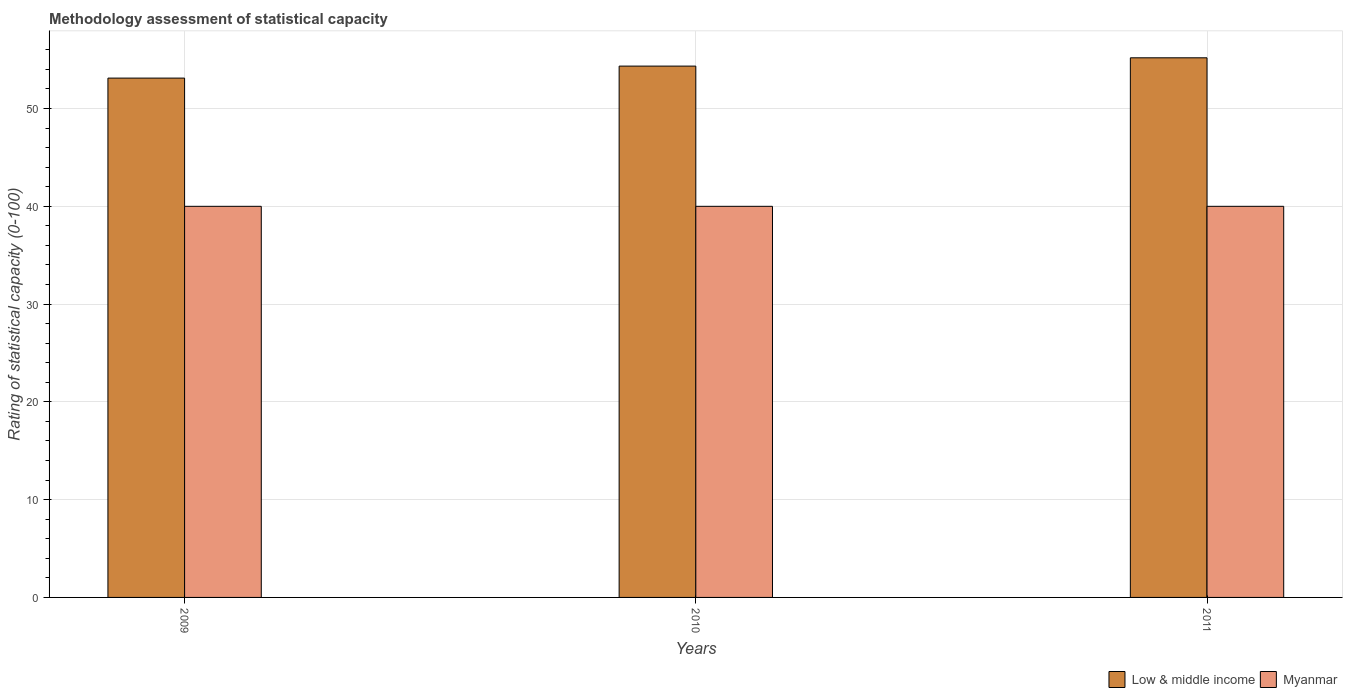How many different coloured bars are there?
Your response must be concise. 2. Are the number of bars per tick equal to the number of legend labels?
Make the answer very short. Yes. Are the number of bars on each tick of the X-axis equal?
Offer a terse response. Yes. How many bars are there on the 1st tick from the left?
Provide a short and direct response. 2. How many bars are there on the 1st tick from the right?
Make the answer very short. 2. What is the label of the 2nd group of bars from the left?
Your response must be concise. 2010. In how many cases, is the number of bars for a given year not equal to the number of legend labels?
Ensure brevity in your answer.  0. What is the rating of statistical capacity in Myanmar in 2011?
Give a very brief answer. 40. Across all years, what is the maximum rating of statistical capacity in Low & middle income?
Make the answer very short. 55.19. Across all years, what is the minimum rating of statistical capacity in Low & middle income?
Provide a succinct answer. 53.11. In which year was the rating of statistical capacity in Myanmar maximum?
Give a very brief answer. 2009. In which year was the rating of statistical capacity in Myanmar minimum?
Offer a very short reply. 2009. What is the total rating of statistical capacity in Myanmar in the graph?
Your answer should be very brief. 120. What is the difference between the rating of statistical capacity in Myanmar in 2011 and the rating of statistical capacity in Low & middle income in 2009?
Offer a terse response. -13.11. What is the average rating of statistical capacity in Low & middle income per year?
Make the answer very short. 54.21. In the year 2010, what is the difference between the rating of statistical capacity in Low & middle income and rating of statistical capacity in Myanmar?
Provide a succinct answer. 14.34. In how many years, is the rating of statistical capacity in Low & middle income greater than 44?
Offer a terse response. 3. What is the ratio of the rating of statistical capacity in Myanmar in 2009 to that in 2010?
Provide a succinct answer. 1. Is the rating of statistical capacity in Low & middle income in 2009 less than that in 2010?
Offer a terse response. Yes. Is the difference between the rating of statistical capacity in Low & middle income in 2009 and 2011 greater than the difference between the rating of statistical capacity in Myanmar in 2009 and 2011?
Keep it short and to the point. No. What is the difference between the highest and the second highest rating of statistical capacity in Low & middle income?
Ensure brevity in your answer.  0.85. What does the 1st bar from the left in 2010 represents?
Offer a very short reply. Low & middle income. What does the 1st bar from the right in 2010 represents?
Your response must be concise. Myanmar. How many bars are there?
Provide a short and direct response. 6. Are all the bars in the graph horizontal?
Offer a very short reply. No. How many years are there in the graph?
Your answer should be very brief. 3. What is the difference between two consecutive major ticks on the Y-axis?
Your response must be concise. 10. Does the graph contain any zero values?
Make the answer very short. No. Does the graph contain grids?
Make the answer very short. Yes. What is the title of the graph?
Give a very brief answer. Methodology assessment of statistical capacity. What is the label or title of the X-axis?
Your response must be concise. Years. What is the label or title of the Y-axis?
Ensure brevity in your answer.  Rating of statistical capacity (0-100). What is the Rating of statistical capacity (0-100) in Low & middle income in 2009?
Keep it short and to the point. 53.11. What is the Rating of statistical capacity (0-100) in Low & middle income in 2010?
Ensure brevity in your answer.  54.34. What is the Rating of statistical capacity (0-100) of Myanmar in 2010?
Ensure brevity in your answer.  40. What is the Rating of statistical capacity (0-100) of Low & middle income in 2011?
Your answer should be compact. 55.19. What is the Rating of statistical capacity (0-100) of Myanmar in 2011?
Offer a terse response. 40. Across all years, what is the maximum Rating of statistical capacity (0-100) of Low & middle income?
Your response must be concise. 55.19. Across all years, what is the maximum Rating of statistical capacity (0-100) of Myanmar?
Provide a short and direct response. 40. Across all years, what is the minimum Rating of statistical capacity (0-100) of Low & middle income?
Provide a succinct answer. 53.11. What is the total Rating of statistical capacity (0-100) of Low & middle income in the graph?
Your response must be concise. 162.64. What is the total Rating of statistical capacity (0-100) of Myanmar in the graph?
Keep it short and to the point. 120. What is the difference between the Rating of statistical capacity (0-100) of Low & middle income in 2009 and that in 2010?
Your answer should be very brief. -1.23. What is the difference between the Rating of statistical capacity (0-100) of Myanmar in 2009 and that in 2010?
Offer a terse response. 0. What is the difference between the Rating of statistical capacity (0-100) of Low & middle income in 2009 and that in 2011?
Your response must be concise. -2.08. What is the difference between the Rating of statistical capacity (0-100) in Low & middle income in 2010 and that in 2011?
Your response must be concise. -0.85. What is the difference between the Rating of statistical capacity (0-100) of Low & middle income in 2009 and the Rating of statistical capacity (0-100) of Myanmar in 2010?
Provide a short and direct response. 13.11. What is the difference between the Rating of statistical capacity (0-100) in Low & middle income in 2009 and the Rating of statistical capacity (0-100) in Myanmar in 2011?
Your answer should be compact. 13.11. What is the difference between the Rating of statistical capacity (0-100) of Low & middle income in 2010 and the Rating of statistical capacity (0-100) of Myanmar in 2011?
Offer a terse response. 14.34. What is the average Rating of statistical capacity (0-100) of Low & middle income per year?
Provide a succinct answer. 54.21. In the year 2009, what is the difference between the Rating of statistical capacity (0-100) of Low & middle income and Rating of statistical capacity (0-100) of Myanmar?
Make the answer very short. 13.11. In the year 2010, what is the difference between the Rating of statistical capacity (0-100) of Low & middle income and Rating of statistical capacity (0-100) of Myanmar?
Offer a very short reply. 14.34. In the year 2011, what is the difference between the Rating of statistical capacity (0-100) of Low & middle income and Rating of statistical capacity (0-100) of Myanmar?
Offer a very short reply. 15.19. What is the ratio of the Rating of statistical capacity (0-100) in Low & middle income in 2009 to that in 2010?
Provide a succinct answer. 0.98. What is the ratio of the Rating of statistical capacity (0-100) in Low & middle income in 2009 to that in 2011?
Keep it short and to the point. 0.96. What is the ratio of the Rating of statistical capacity (0-100) of Myanmar in 2009 to that in 2011?
Your answer should be compact. 1. What is the ratio of the Rating of statistical capacity (0-100) in Low & middle income in 2010 to that in 2011?
Offer a very short reply. 0.98. What is the difference between the highest and the second highest Rating of statistical capacity (0-100) of Low & middle income?
Your answer should be very brief. 0.85. What is the difference between the highest and the second highest Rating of statistical capacity (0-100) of Myanmar?
Give a very brief answer. 0. What is the difference between the highest and the lowest Rating of statistical capacity (0-100) of Low & middle income?
Offer a terse response. 2.08. What is the difference between the highest and the lowest Rating of statistical capacity (0-100) in Myanmar?
Your answer should be compact. 0. 